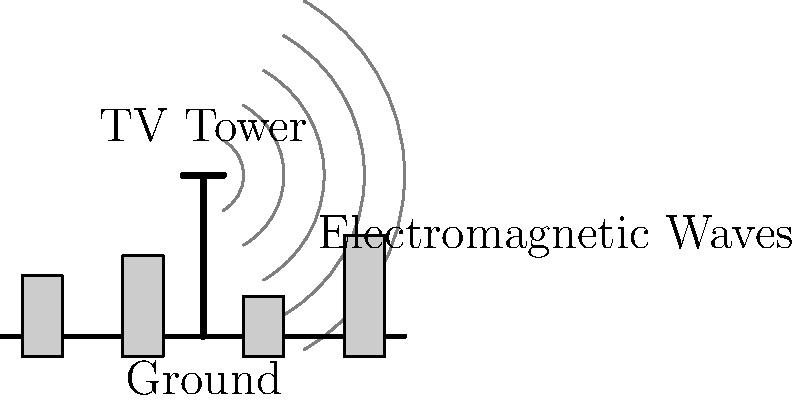In Hong Kong's urban environment, TV broadcasting relies heavily on electromagnetic wave propagation. Consider a TV tower transmitting signals at a frequency of 600 MHz. If the signal strength at a distance of 5 km from the tower is measured to be 50 μW/m², what would be the approximate signal strength at a distance of 10 km, assuming ideal free-space propagation? To solve this problem, we need to understand how electromagnetic waves propagate in free space. The key concepts are:

1. The inverse square law for electromagnetic radiation.
2. The relationship between distance and signal strength.

Step 1: Recall the inverse square law
The power density (signal strength) is inversely proportional to the square of the distance from the source.

$$ P_1 d_1^2 = P_2 d_2^2 $$

Where:
$P_1$ and $P_2$ are power densities at distances $d_1$ and $d_2$ respectively.

Step 2: Identify the known values
$P_1 = 50 \text{ μW/m²}$
$d_1 = 5 \text{ km}$
$d_2 = 10 \text{ km}$

Step 3: Set up the equation
$$ 50 \cdot 5^2 = P_2 \cdot 10^2 $$

Step 4: Solve for $P_2$
$$ P_2 = \frac{50 \cdot 5^2}{10^2} = \frac{50 \cdot 25}{100} = 12.5 \text{ μW/m²} $$

Therefore, at a distance of 10 km, the signal strength would be approximately 12.5 μW/m².

Note: This calculation assumes ideal free-space propagation. In reality, Hong Kong's dense urban environment with tall buildings would cause reflections, diffractions, and absorptions, leading to more complex signal propagation patterns.
Answer: 12.5 μW/m² 